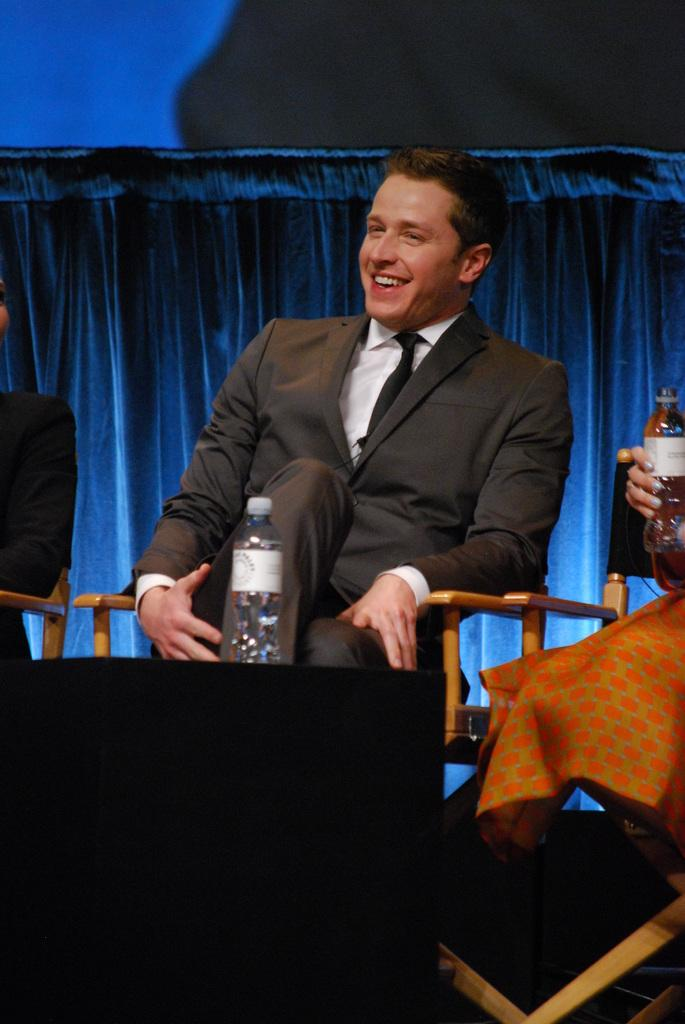What is the man in the image doing? The man is sitting on a chair in the image. How does the man appear to be feeling in the image? The man has a smile on his face, indicating that he is happy or content. What is the man holding in the image? There is a water bottle in the image. What type of clothing is the man wearing? The man is wearing a suit and a tie. What color is the friend's shirt in the image? There is no friend present in the image, only the man sitting on a chair. What caused the man to smile in the image? The facts provided do not give any information about the cause of the man's smile. 